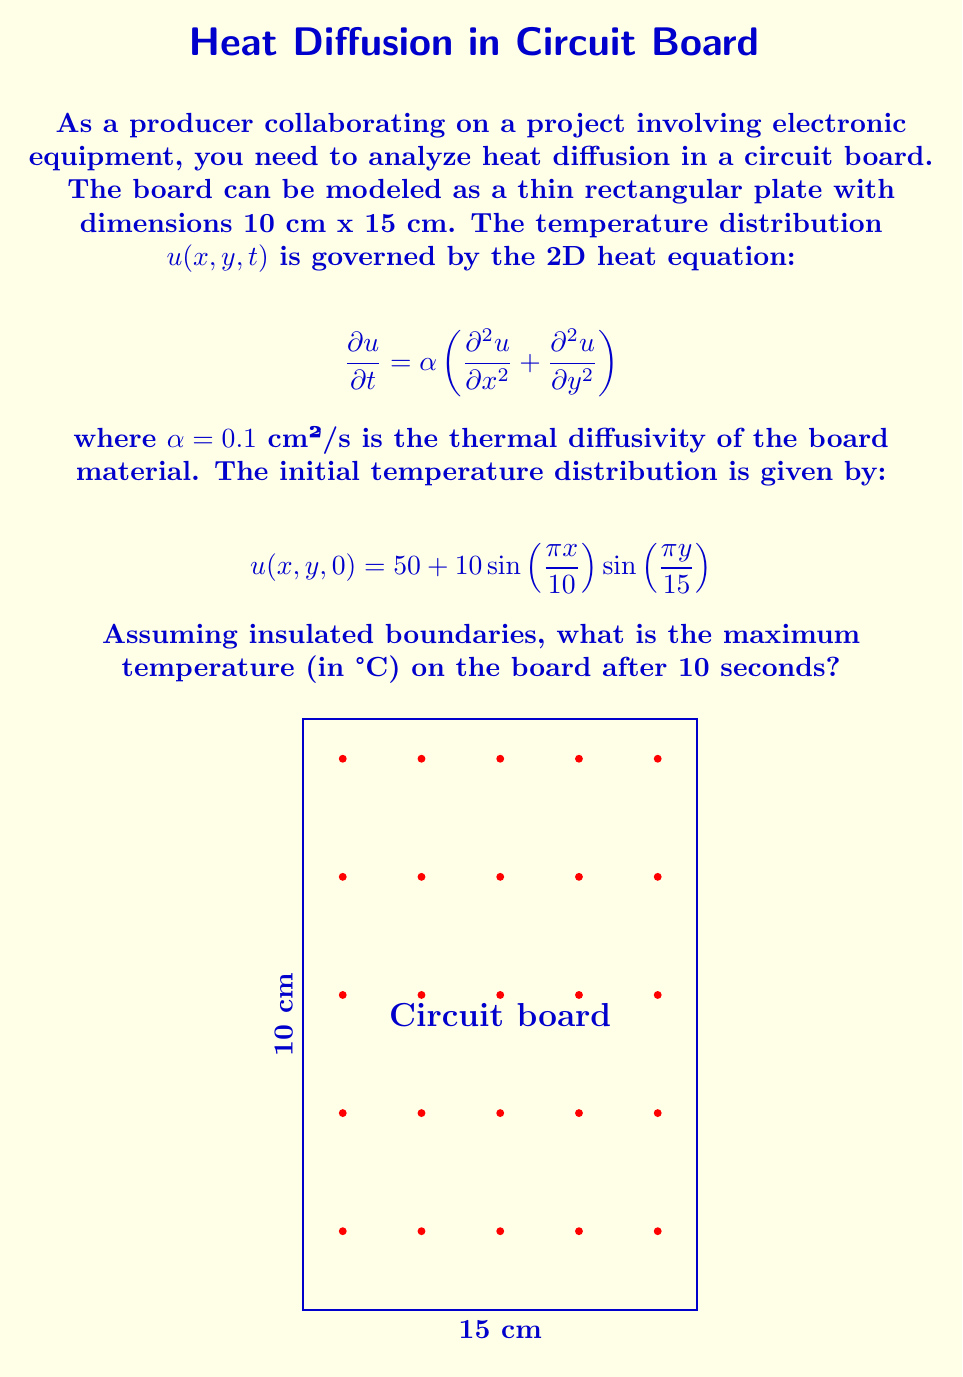Solve this math problem. To solve this problem, we'll follow these steps:

1) The general solution to the 2D heat equation with insulated boundaries is:

   $$u(x,y,t) = \sum_{m=0}^{\infty}\sum_{n=0}^{\infty} A_{mn} \cos\left(\frac{m\pi x}{L_x}\right)\cos\left(\frac{n\pi y}{L_y}\right)e^{-\alpha((\frac{m\pi}{L_x})^2+(\frac{n\pi}{L_y})^2)t}$$

   where $L_x = 10$ cm and $L_y = 15$ cm.

2) The initial condition matches this form with $m=n=1$ and a constant term:

   $$u(x,y,0) = 50 + 10\sin\left(\frac{\pi x}{10}\right)\sin\left(\frac{\pi y}{15}\right)$$

3) We can rewrite this as:

   $$u(x,y,0) = 50 + 10\cos\left(\frac{\pi x}{10} - \frac{\pi}{2}\right)\cos\left(\frac{\pi y}{15} - \frac{\pi}{2}\right)$$

4) Therefore, $A_{00} = 50$ and $A_{11} = 10$, with all other $A_{mn} = 0$.

5) The solution at time $t$ is:

   $$u(x,y,t) = 50 + 10\cos\left(\frac{\pi x}{10} - \frac{\pi}{2}\right)\cos\left(\frac{\pi y}{15} - \frac{\pi}{2}\right)e^{-\alpha((\frac{\pi}{10})^2+(\frac{\pi}{15})^2)t}$$

6) Simplifying:

   $$u(x,y,t) = 50 + 10\sin\left(\frac{\pi x}{10}\right)\sin\left(\frac{\pi y}{15}\right)e^{-0.1((\frac{\pi}{10})^2+(\frac{\pi}{15})^2)10}$$

7) Calculate the exponential term:

   $$e^{-0.1((\frac{\pi}{10})^2+(\frac{\pi}{15})^2)10} \approx 0.7114$$

8) Therefore, after 10 seconds:

   $$u(x,y,10) = 50 + 7.114\sin\left(\frac{\pi x}{10}\right)\sin\left(\frac{\pi y}{15}\right)$$

9) The maximum temperature occurs where the sine terms are at their maximum (1), so:

   $$u_{max} = 50 + 7.114 = 57.114°C$$
Answer: 57.114°C 